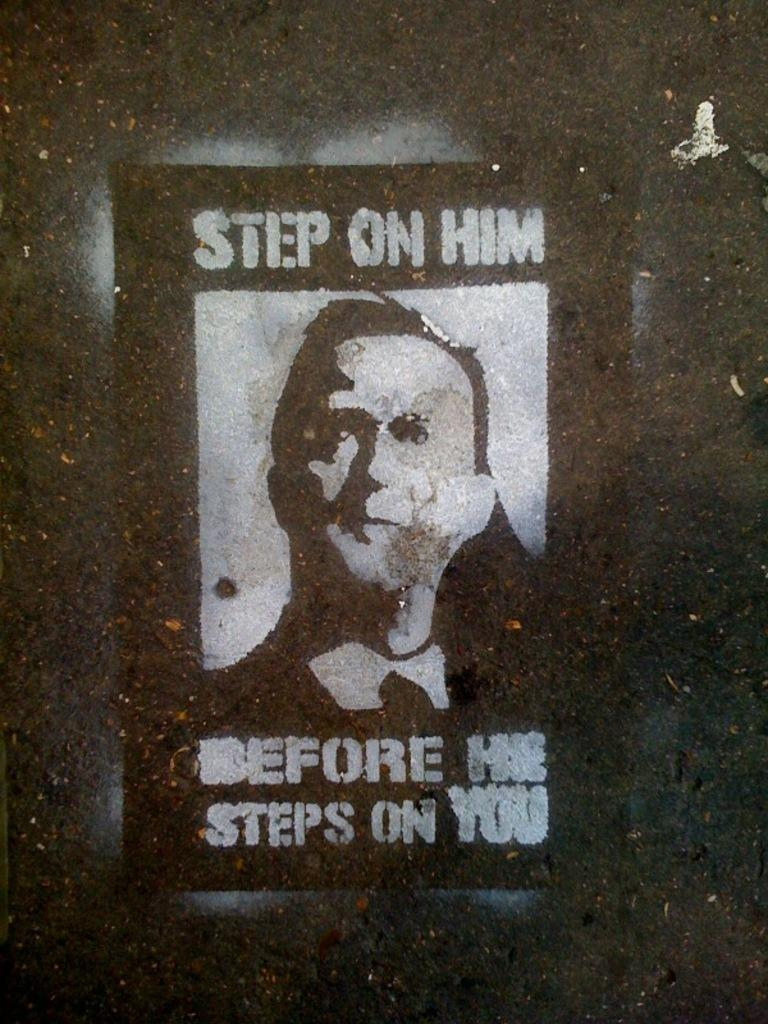What is featured on the poster in the image? The poster contains a picture of a person. What else can be found on the poster besides the image? There is text on the poster. What type of copper paste is used to create the image on the poster? There is no mention of copper paste or any type of paste in the image or the provided facts. The image features a poster with a picture of a person and text, but no information about the materials used to create the poster is given. 